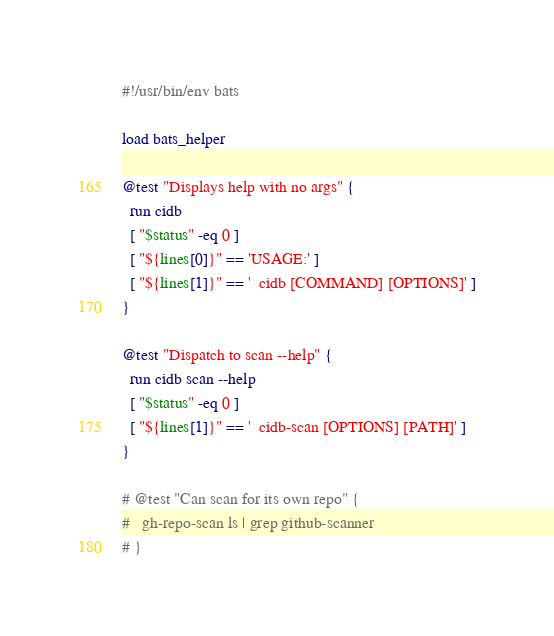<code> <loc_0><loc_0><loc_500><loc_500><_Bash_>#!/usr/bin/env bats

load bats_helper

@test "Displays help with no args" {
  run cidb
  [ "$status" -eq 0 ]
  [ "${lines[0]}" == 'USAGE:' ]
  [ "${lines[1]}" == '  cidb [COMMAND] [OPTIONS]' ]
}

@test "Dispatch to scan --help" {
  run cidb scan --help
  [ "$status" -eq 0 ]
  [ "${lines[1]}" == '  cidb-scan [OPTIONS] [PATH]' ]
}

# @test "Can scan for its own repo" {
#   gh-repo-scan ls | grep github-scanner
# }
</code> 